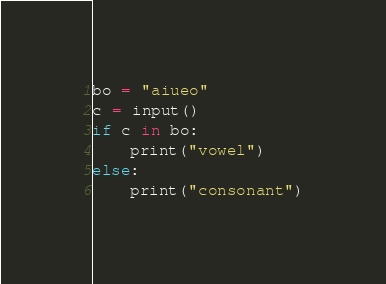Convert code to text. <code><loc_0><loc_0><loc_500><loc_500><_Python_>bo = "aiueo"
c = input()
if c in bo:
    print("vowel")
else:
    print("consonant")</code> 